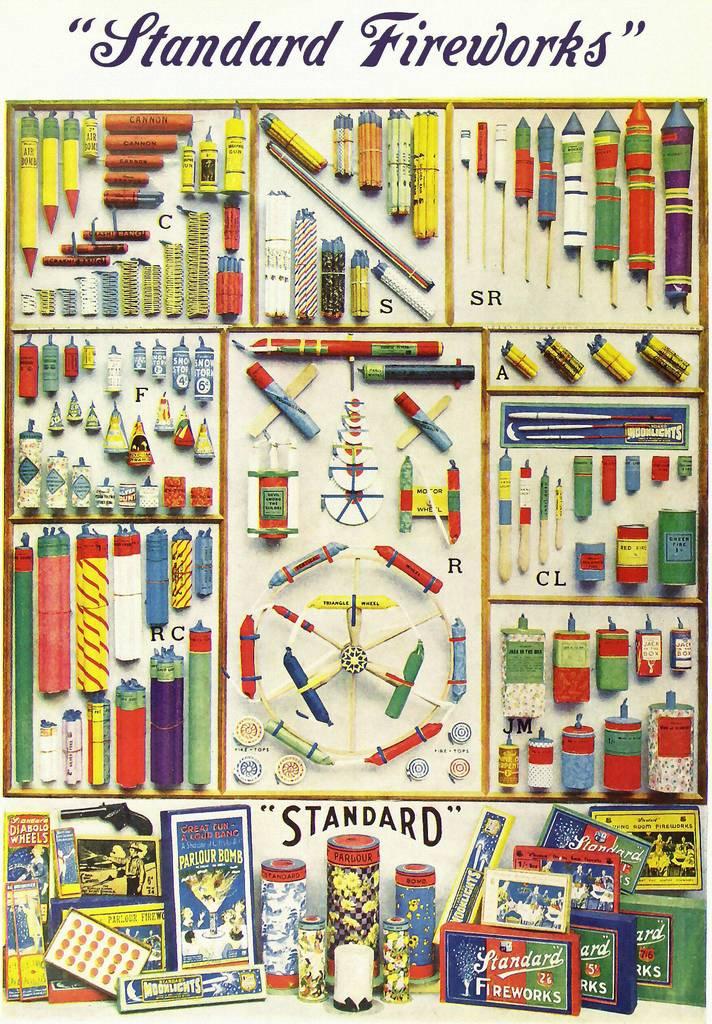Where can i buy these fireworks?
Ensure brevity in your answer.  Standard. What kind of fireworks are these?
Your answer should be very brief. Standard. 